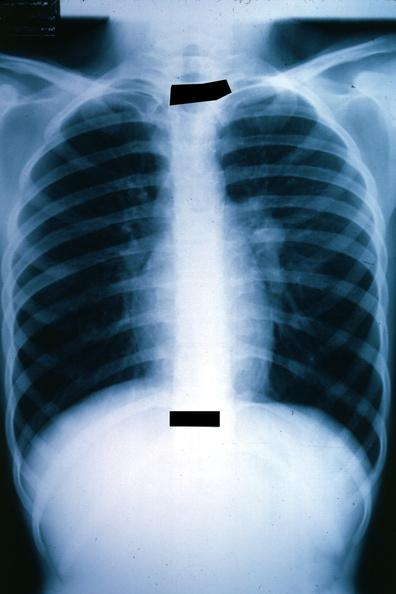does this image show x-ray chest well shown left hilar mass tumor in hilar node?
Answer the question using a single word or phrase. Yes 